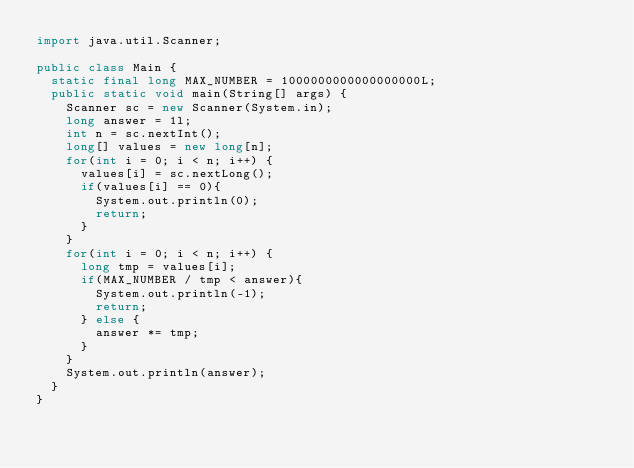<code> <loc_0><loc_0><loc_500><loc_500><_Java_>import java.util.Scanner;

public class Main {
  static final long MAX_NUMBER = 1000000000000000000L;
  public static void main(String[] args) {
    Scanner sc = new Scanner(System.in);
    long answer = 1l;
    int n = sc.nextInt();
    long[] values = new long[n];
    for(int i = 0; i < n; i++) {
      values[i] = sc.nextLong();
      if(values[i] == 0){
        System.out.println(0);
        return;
      }
    }
    for(int i = 0; i < n; i++) {
      long tmp = values[i];
      if(MAX_NUMBER / tmp < answer){
        System.out.println(-1);
        return;
      } else {
        answer *= tmp;
      }
    }
    System.out.println(answer);
  }
}</code> 